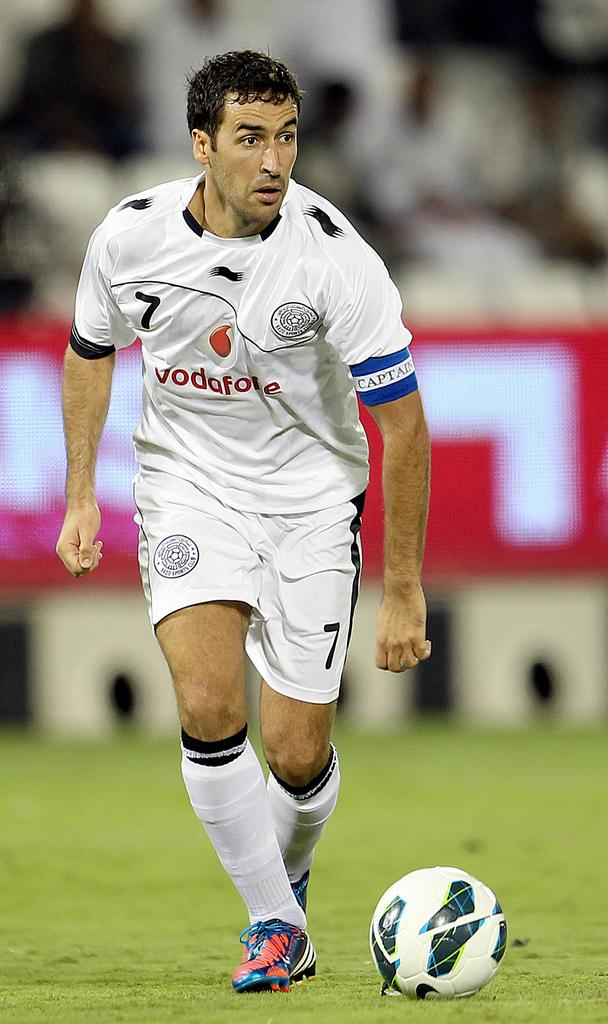What is the main subject of the image? There is a person standing in the image. What is the person wearing? The person is wearing a white dress. What other object can be seen in the image? There is a white ball in the image. Can you describe the background of the image? The background of the image is blurred. What is the purpose of the nail in the image? There is no nail present in the image. How many bits are visible in the image? There are no bits present in the image. 